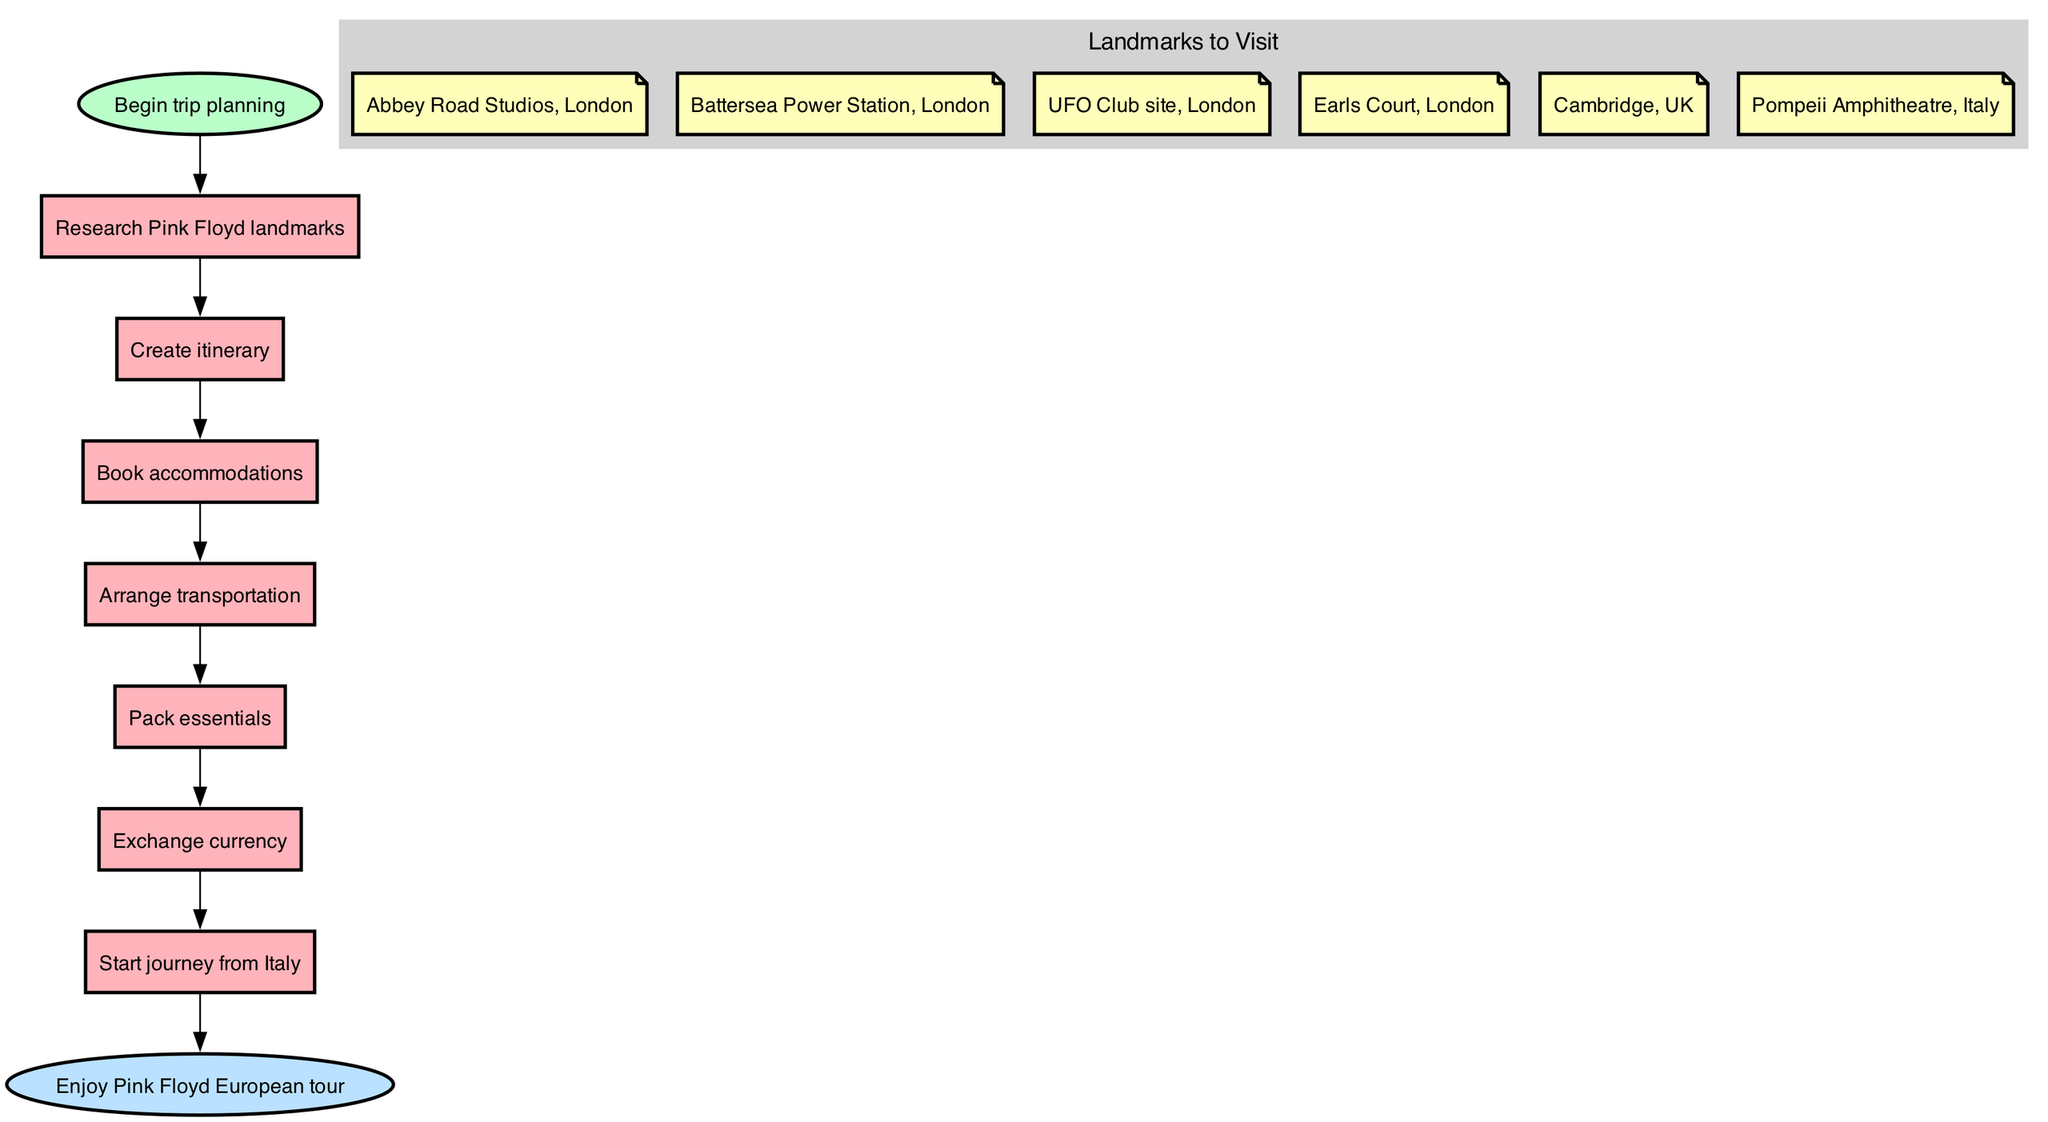What is the first step in planning the trip? The diagram indicates that the first step in the trip planning process is to "Research Pink Floyd landmarks." This can be identified by looking for the initial step connected to the start node.
Answer: Research Pink Floyd landmarks How many significant landmarks are listed in the diagram? By examining the landmarks subgraph in the diagram, we can count the number of unique landmarks mentioned. There are six distinct landmarks listed, which are outlined separately within the subgraph.
Answer: Six What comes after "Pack essentials"? The flowchart shows that the step following "Pack essentials" is "Exchange currency." This can be deduced by moving sequentially through the steps of the diagram, following the directed edges from one step to the next.
Answer: Exchange currency Which landmark is located in Italy? The diagram specifically highlights "Pompeii Amphitheatre" as one of the landmarks and it is indicated as being located in Italy. Thus, upon review, this landmark serves as the answer as it stands out among others which are located in the UK.
Answer: Pompeii Amphitheatre, Italy What is the last step before starting the journey? Observing the sequence, the step just before "Start journey from Italy" is "Exchange currency." By following the connections within the flowchart, we can identify this step as the preceding action before commencing the actual trip.
Answer: Exchange currency How many steps are in the itinerary? The diagram displays a total of six steps in the itinerary, which can be counted by sequentially listing each step from "Research Pink Floyd landmarks" through to "Start journey from Italy." Each of these steps forms part of the planning process for the trip.
Answer: Six What is the final outcome of planning the trip? The end node of the flowchart states, "Enjoy Pink Floyd European tour," which summarizes the final outcome of all the prior planning steps. This can be confirmed by looking at the directed edge that leads to the end node.
Answer: Enjoy Pink Floyd European tour What connects "Book accommodations" and "Arrange transportation"? In the flowchart, there is a direct edge leading from "Book accommodations" to "Arrange transportation," indicating a clear relationship and order between these two steps. By examining their ordering, we can conclude that "Book accommodations" leads directly into transportation arrangements.
Answer: Arrange transportation 